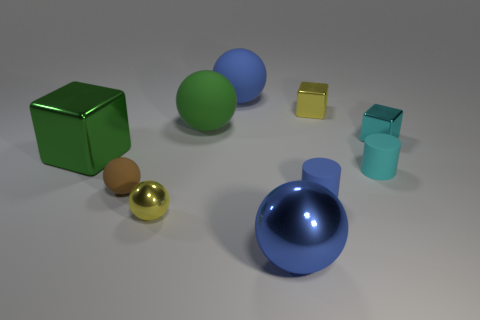Are there any big matte cylinders of the same color as the large metal ball?
Keep it short and to the point. No. What number of small things are rubber objects or metallic balls?
Make the answer very short. 4. What number of big red matte blocks are there?
Make the answer very short. 0. There is a large blue sphere that is in front of the brown thing; what material is it?
Give a very brief answer. Metal. Are there any large blue spheres in front of the tiny rubber sphere?
Your answer should be compact. Yes. Does the yellow metal sphere have the same size as the cyan metal thing?
Offer a terse response. Yes. How many tiny things are the same material as the yellow cube?
Your answer should be compact. 2. What is the size of the metal sphere that is behind the large metallic object on the right side of the green cube?
Provide a succinct answer. Small. What color is the object that is both to the left of the big blue matte ball and in front of the brown sphere?
Provide a short and direct response. Yellow. Does the brown rubber thing have the same shape as the green matte object?
Give a very brief answer. Yes. 